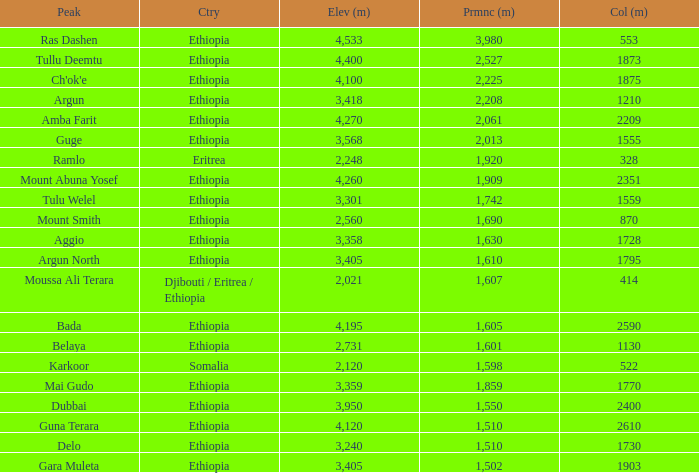What is the sum of the prominence in m of moussa ali terara peak? 1607.0. 